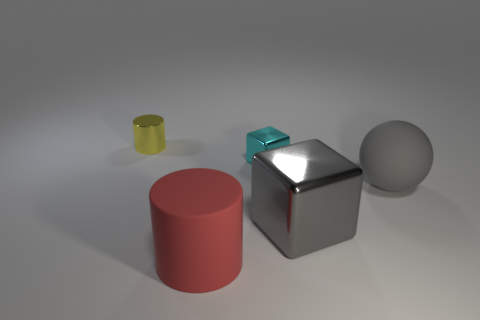Subtract all balls. How many objects are left? 4 Add 4 red rubber cylinders. How many objects exist? 9 Subtract all large purple metal things. Subtract all red matte objects. How many objects are left? 4 Add 4 cyan shiny things. How many cyan shiny things are left? 5 Add 2 yellow metal cylinders. How many yellow metal cylinders exist? 3 Subtract 0 gray cylinders. How many objects are left? 5 